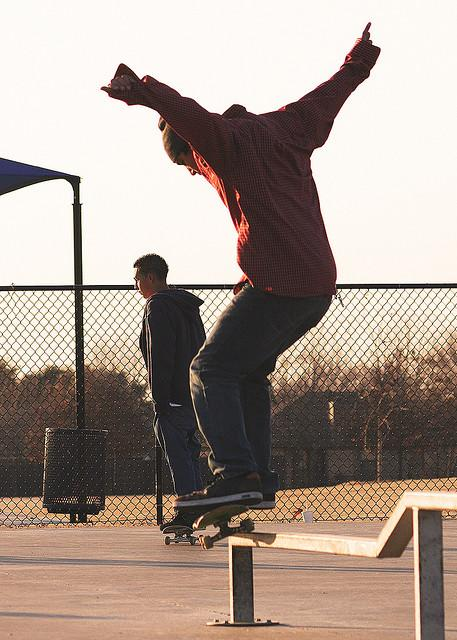What is the skater doing on the rail?

Choices:
A) grinding
B) flipping
C) manualing
D) whipping grinding 